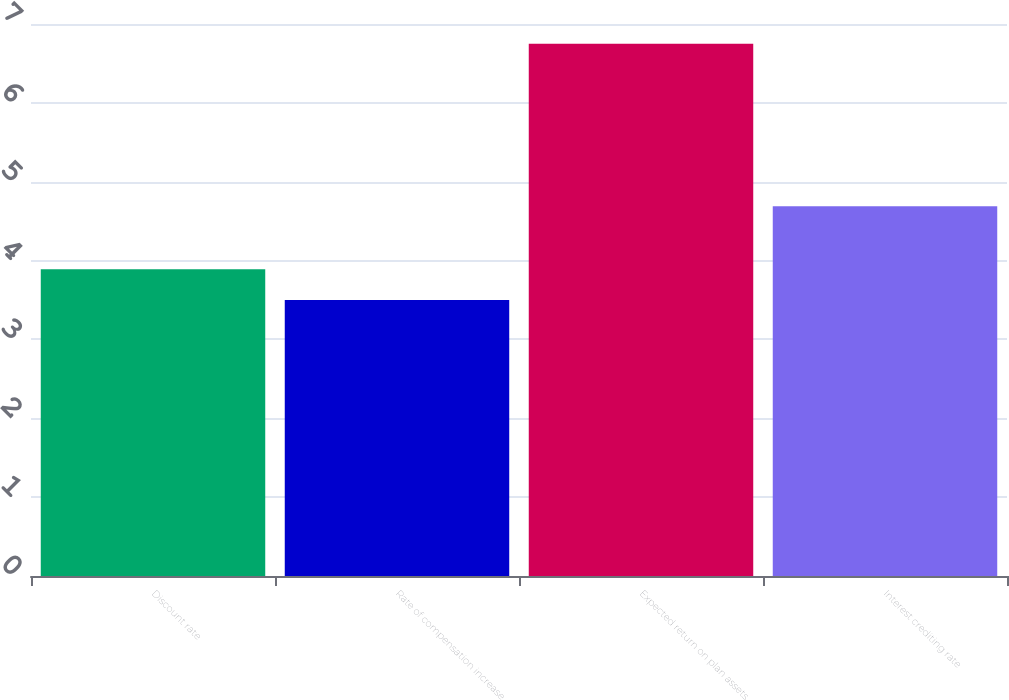Convert chart. <chart><loc_0><loc_0><loc_500><loc_500><bar_chart><fcel>Discount rate<fcel>Rate of compensation increase<fcel>Expected return on plan assets<fcel>Interest crediting rate<nl><fcel>3.89<fcel>3.5<fcel>6.75<fcel>4.69<nl></chart> 